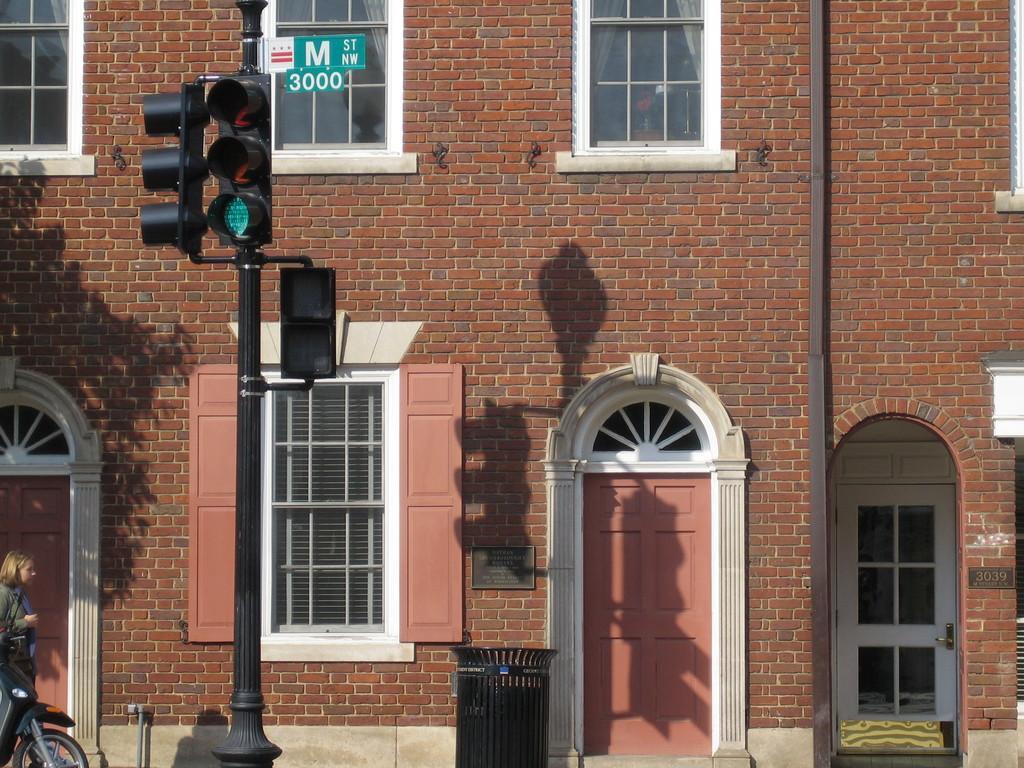Could you give a brief overview of what you see in this image? In this image there is a building and the building is constructed with bricks. There is also a traffic signal pole and also a bike visible in this image. On the left there is a woman. Trash bin is also visible 